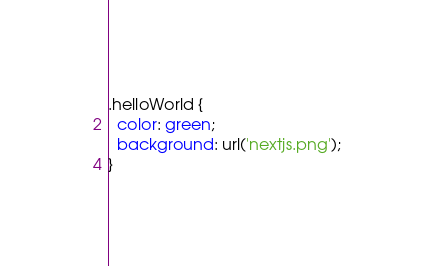Convert code to text. <code><loc_0><loc_0><loc_500><loc_500><_CSS_>.helloWorld {
  color: green;
  background: url('nextjs.png');
}
</code> 